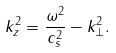<formula> <loc_0><loc_0><loc_500><loc_500>k _ { z } ^ { 2 } = \frac { \omega ^ { 2 } } { c _ { s } ^ { 2 } } - k _ { \bot } ^ { 2 } .</formula> 